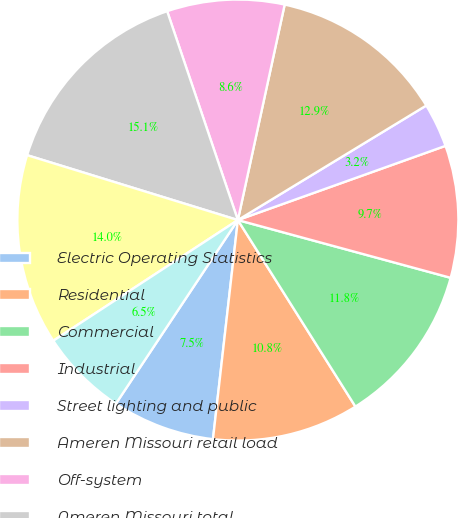Convert chart. <chart><loc_0><loc_0><loc_500><loc_500><pie_chart><fcel>Electric Operating Statistics<fcel>Residential<fcel>Commercial<fcel>Industrial<fcel>Street lighting and public<fcel>Ameren Missouri retail load<fcel>Off-system<fcel>Ameren Missouri total<fcel>Ameren Illinois Electric<fcel>Eliminate affiliate sales<nl><fcel>7.53%<fcel>10.75%<fcel>11.83%<fcel>9.68%<fcel>3.23%<fcel>12.9%<fcel>8.6%<fcel>15.05%<fcel>13.97%<fcel>6.45%<nl></chart> 